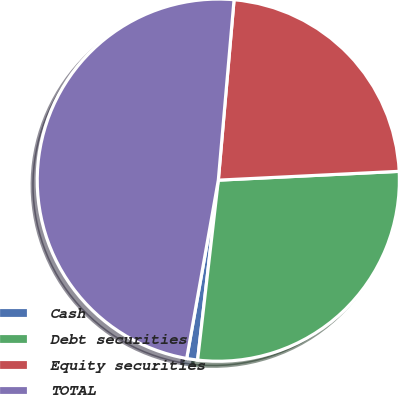<chart> <loc_0><loc_0><loc_500><loc_500><pie_chart><fcel>Cash<fcel>Debt securities<fcel>Equity securities<fcel>TOTAL<nl><fcel>0.97%<fcel>27.6%<fcel>22.84%<fcel>48.59%<nl></chart> 